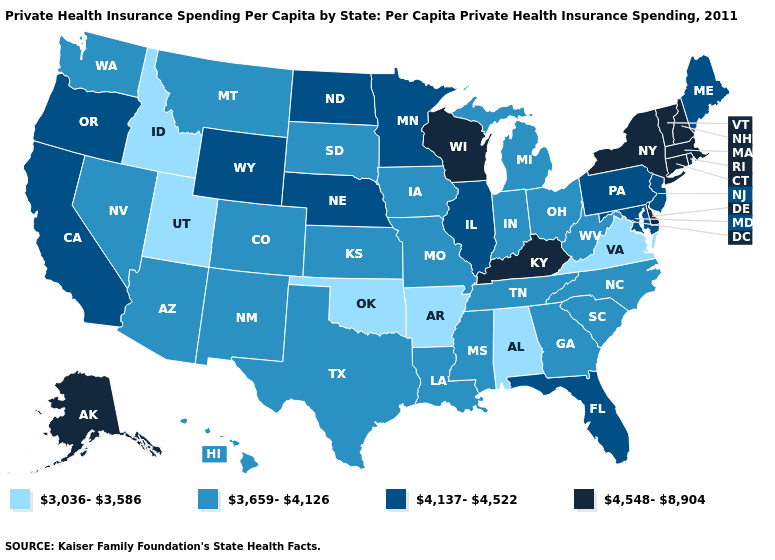Name the states that have a value in the range 4,137-4,522?
Write a very short answer. California, Florida, Illinois, Maine, Maryland, Minnesota, Nebraska, New Jersey, North Dakota, Oregon, Pennsylvania, Wyoming. Does the first symbol in the legend represent the smallest category?
Write a very short answer. Yes. What is the value of North Dakota?
Keep it brief. 4,137-4,522. Which states have the lowest value in the USA?
Write a very short answer. Alabama, Arkansas, Idaho, Oklahoma, Utah, Virginia. What is the lowest value in states that border Utah?
Concise answer only. 3,036-3,586. Among the states that border Tennessee , does Alabama have the lowest value?
Write a very short answer. Yes. Does Tennessee have the same value as Washington?
Concise answer only. Yes. Which states have the lowest value in the Northeast?
Concise answer only. Maine, New Jersey, Pennsylvania. Name the states that have a value in the range 3,659-4,126?
Be succinct. Arizona, Colorado, Georgia, Hawaii, Indiana, Iowa, Kansas, Louisiana, Michigan, Mississippi, Missouri, Montana, Nevada, New Mexico, North Carolina, Ohio, South Carolina, South Dakota, Tennessee, Texas, Washington, West Virginia. Among the states that border Minnesota , does Wisconsin have the lowest value?
Keep it brief. No. Name the states that have a value in the range 4,137-4,522?
Concise answer only. California, Florida, Illinois, Maine, Maryland, Minnesota, Nebraska, New Jersey, North Dakota, Oregon, Pennsylvania, Wyoming. What is the value of North Carolina?
Concise answer only. 3,659-4,126. What is the value of Massachusetts?
Quick response, please. 4,548-8,904. What is the highest value in states that border Texas?
Be succinct. 3,659-4,126. How many symbols are there in the legend?
Answer briefly. 4. 